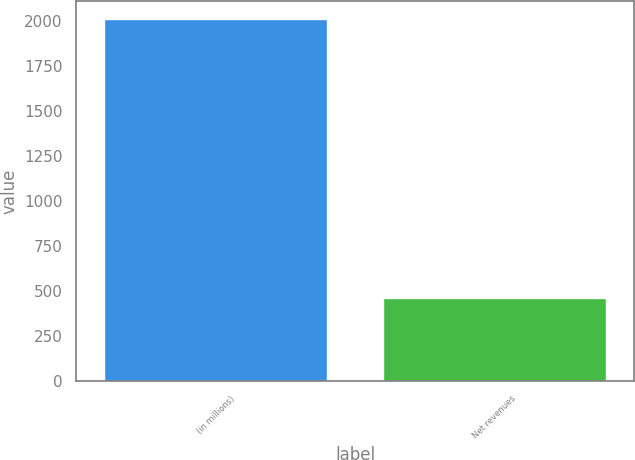Convert chart. <chart><loc_0><loc_0><loc_500><loc_500><bar_chart><fcel>(in millions)<fcel>Net revenues<nl><fcel>2010<fcel>459<nl></chart> 